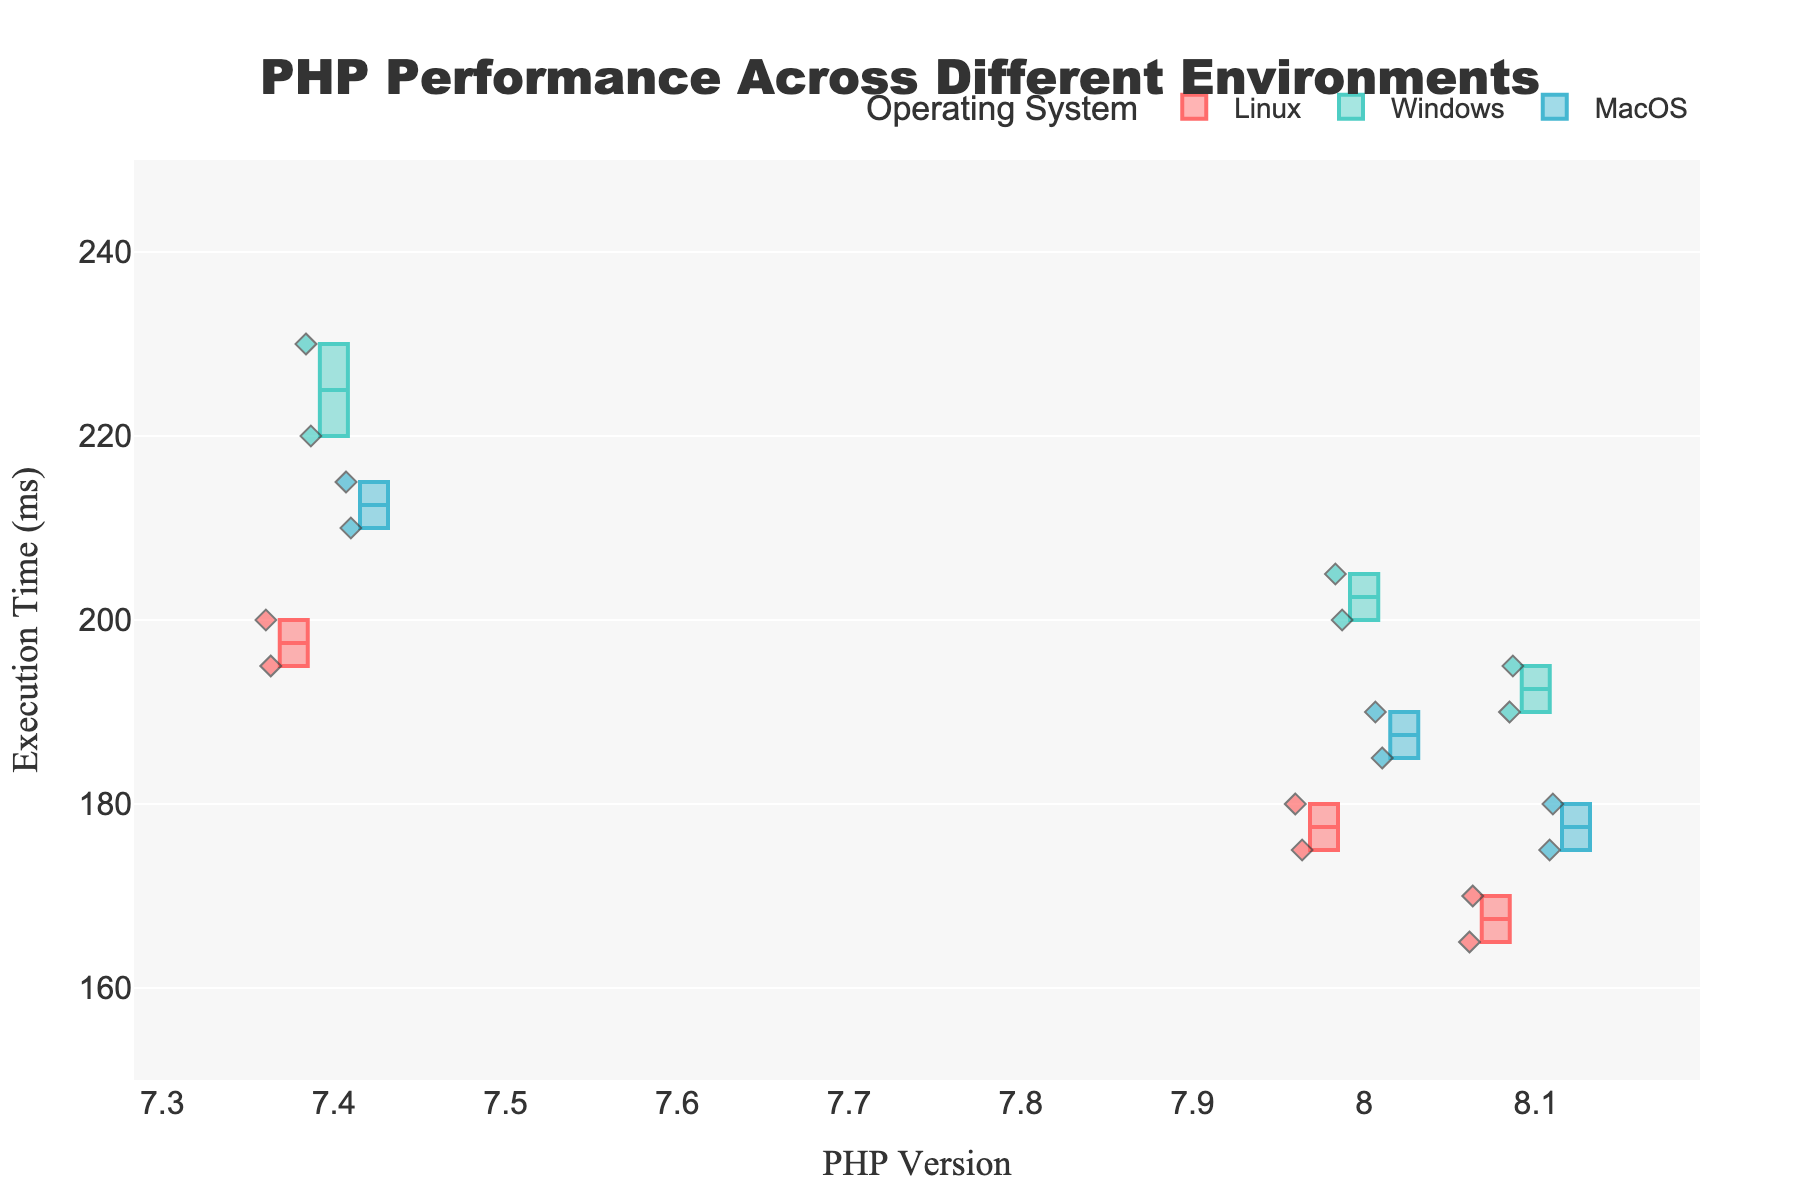What is the title of the plot? The title is prominently displayed at the top of the plot and serves to describe the overall content or the main subject that the plot is addressing. In this case, it describes the performance of PHP across different environments.
Answer: PHP Performance Across Different Environments What does the y-axis represent? Referring to the labels on the y-axis, it represents a specific measurement. In this situation, it indicates a measure of time.
Answer: Execution Time (ms) Which PHP version has the lowest median execution time on Linux? The median value of a box plot is usually marked by a line inside the box. By comparing the median lines for each PHP version under the Linux category, we can identify the version with the lowest median execution time.
Answer: PHP 8.1 Which operating system generally shows the highest execution times for PHP 7.4? By looking at the spread and position of the boxes and whiskers for PHP 7.4 across different operating systems, we can see which has the highest typical values.
Answer: Windows What's the median execution time for PHP 8.0 on MacOS? The median execution time is indicated by the line inside the box of the corresponding category. Checking the PHP 8.0 box for MacOS will show this value.
Answer: 190 ms Between PHP 8.0 and PHP 8.1, which version performs better on average across all operating systems? To determine the average performance, we look at the median execution times represented by the lines within the boxes for each version across all OS categories. The version with consistently lower medians performs better.
Answer: PHP 8.1 What is the interquartile range (IQR) of execution times for PHP 8.1 on Windows? The IQR is the range between the first quartile (Q1) and the third quartile (Q3), represented by the lower and upper bounds of the box. By reading these values for PHP 8.1 on Windows, we can calculate the IQR.
Answer: 190 ms - 175 ms = 15 ms For which PHP version and operating system combination is the maximum execution time observed? The maximum execution time is indicated by the top whisker or the highest outlier point. By comparing these across all categories, we can find the highest point.
Answer: PHP 7.4 on Windows 